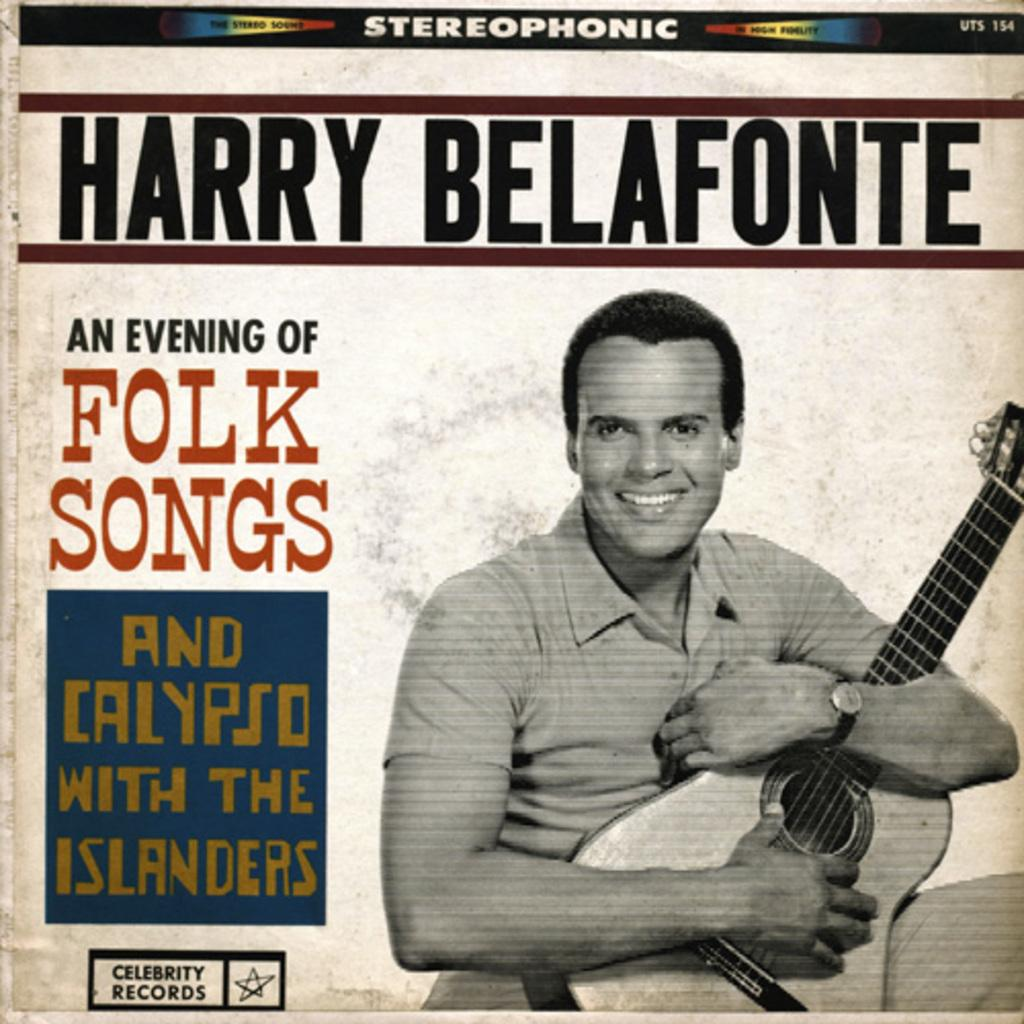What type of visual is depicted in the image? The image is a poster. Who or what is featured in the poster? There is a person in the poster. What is the person holding in the poster? The person is holding a guitar. What else can be seen on the poster besides the person and the guitar? There is text on the poster. What type of stick is the person using to play the guitar in the poster? There is no stick visible in the poster; the person is holding a guitar without any additional objects. What color are the trousers the person is wearing in the poster? The provided facts do not mention the color or type of clothing the person is wearing, so we cannot determine the color of their trousers. 